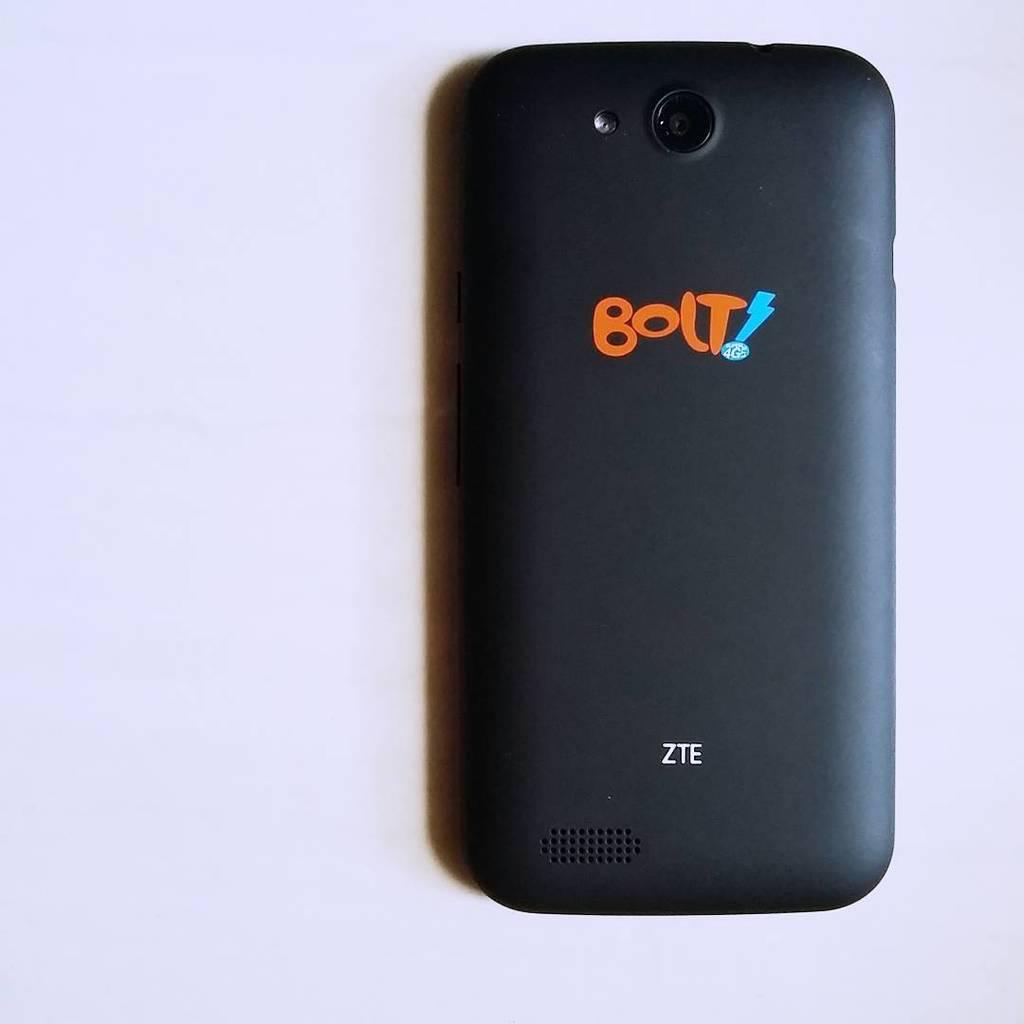Who makes the bolt?
Provide a succinct answer. Zte. 